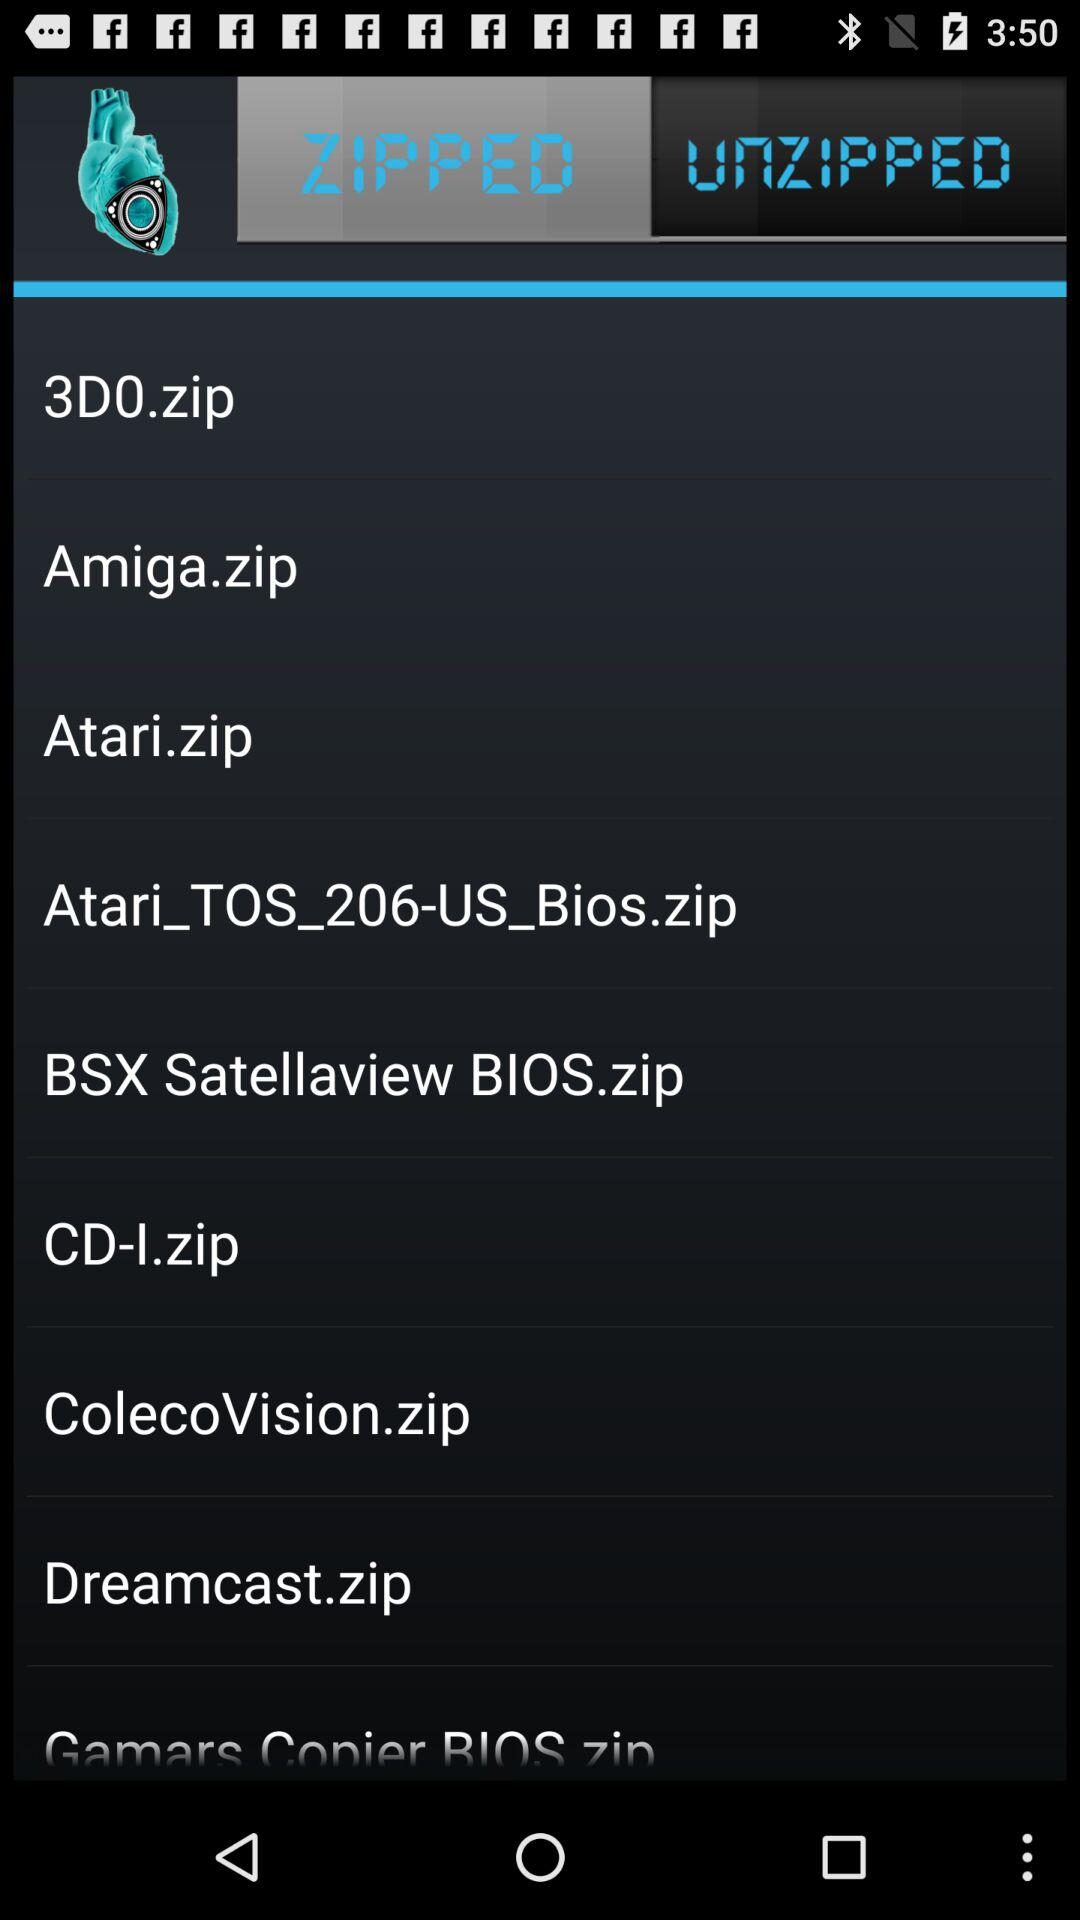Which tab is selected? The selected tab is "ZIPPED". 